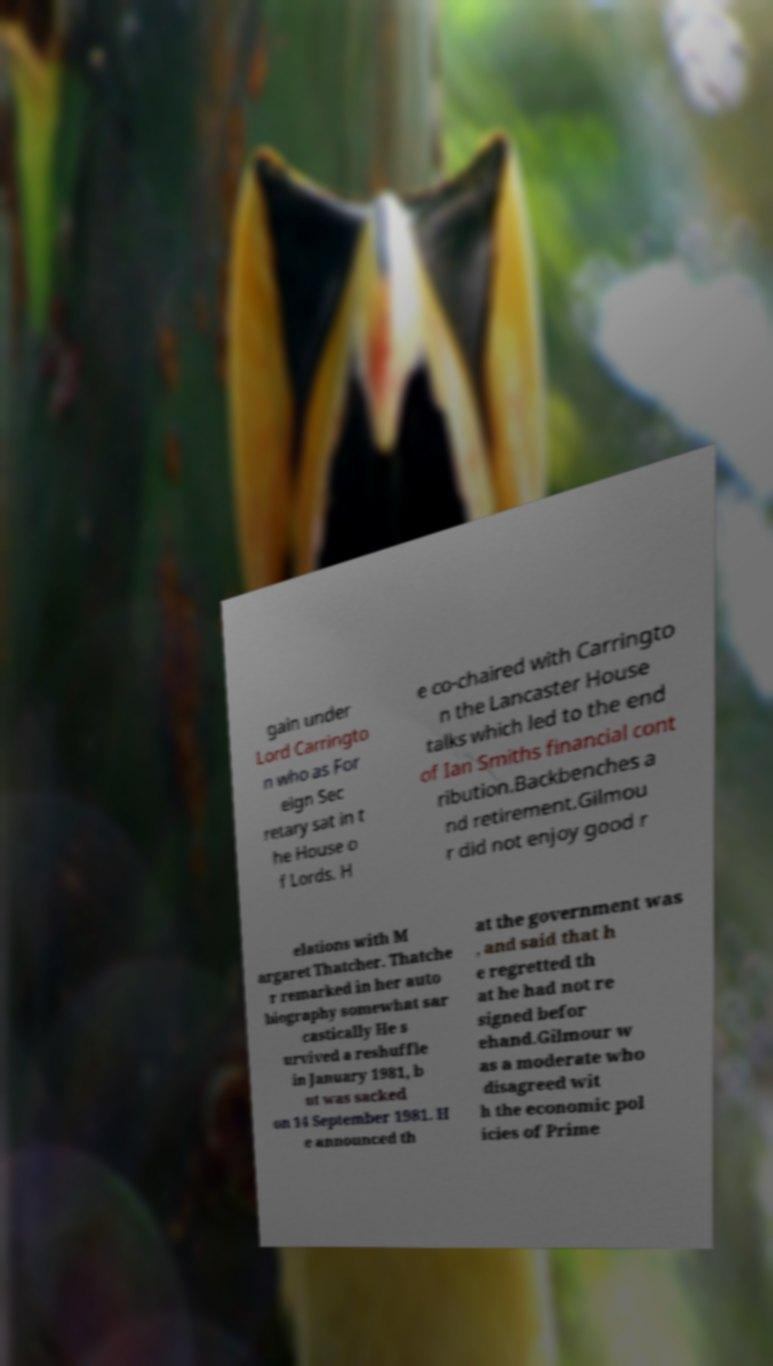Can you read and provide the text displayed in the image?This photo seems to have some interesting text. Can you extract and type it out for me? gain under Lord Carringto n who as For eign Sec retary sat in t he House o f Lords. H e co-chaired with Carringto n the Lancaster House talks which led to the end of Ian Smiths financial cont ribution.Backbenches a nd retirement.Gilmou r did not enjoy good r elations with M argaret Thatcher. Thatche r remarked in her auto biography somewhat sar castically He s urvived a reshuffle in January 1981, b ut was sacked on 14 September 1981. H e announced th at the government was , and said that h e regretted th at he had not re signed befor ehand.Gilmour w as a moderate who disagreed wit h the economic pol icies of Prime 